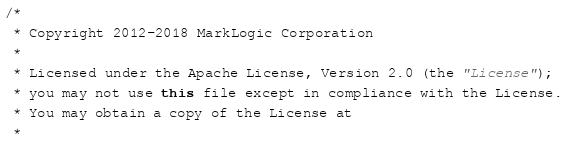<code> <loc_0><loc_0><loc_500><loc_500><_Java_>/*
 * Copyright 2012-2018 MarkLogic Corporation
 *
 * Licensed under the Apache License, Version 2.0 (the "License");
 * you may not use this file except in compliance with the License.
 * You may obtain a copy of the License at
 *</code> 